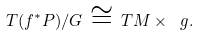Convert formula to latex. <formula><loc_0><loc_0><loc_500><loc_500>T ( f ^ { \ast } P ) / G \, \cong \, T M \times { \ g } .</formula> 